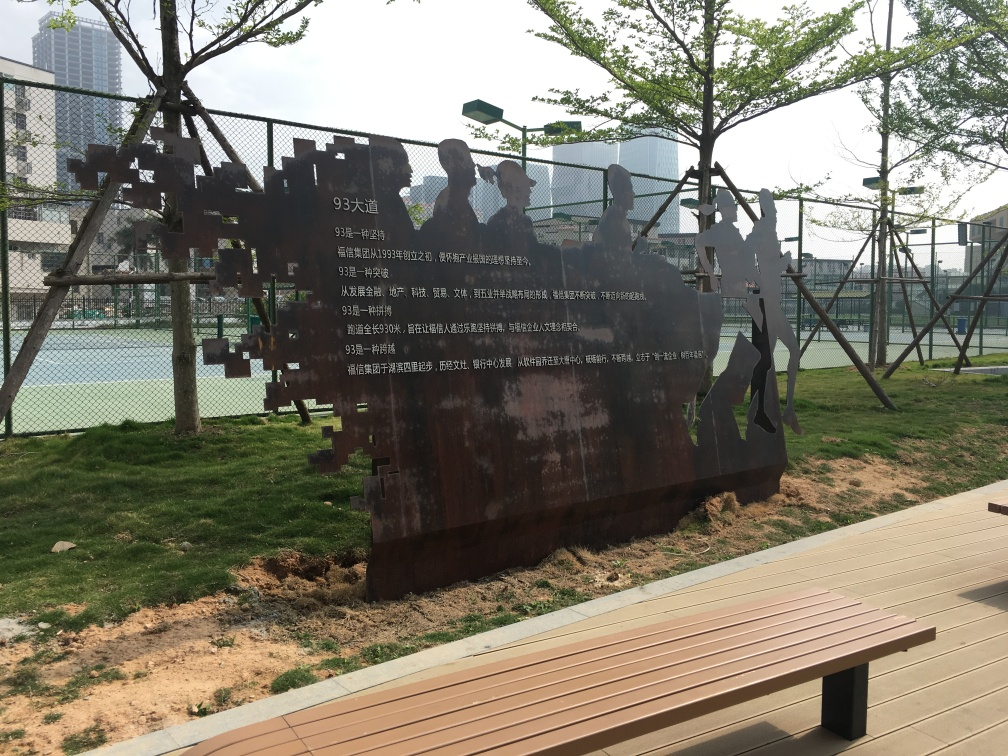Is there a specific mood or atmosphere that this image conveys? The image exudes a contemplative and somewhat nostalgic atmosphere. The rusted metal artwork juxtaposed with the freshness of the green trees and grass suggests a contrast between the past and the present, perhaps hinting at the passage of time. The solidity of the metal figures against the soft, living background of the park also creates a serene but thought-provoking environment. 